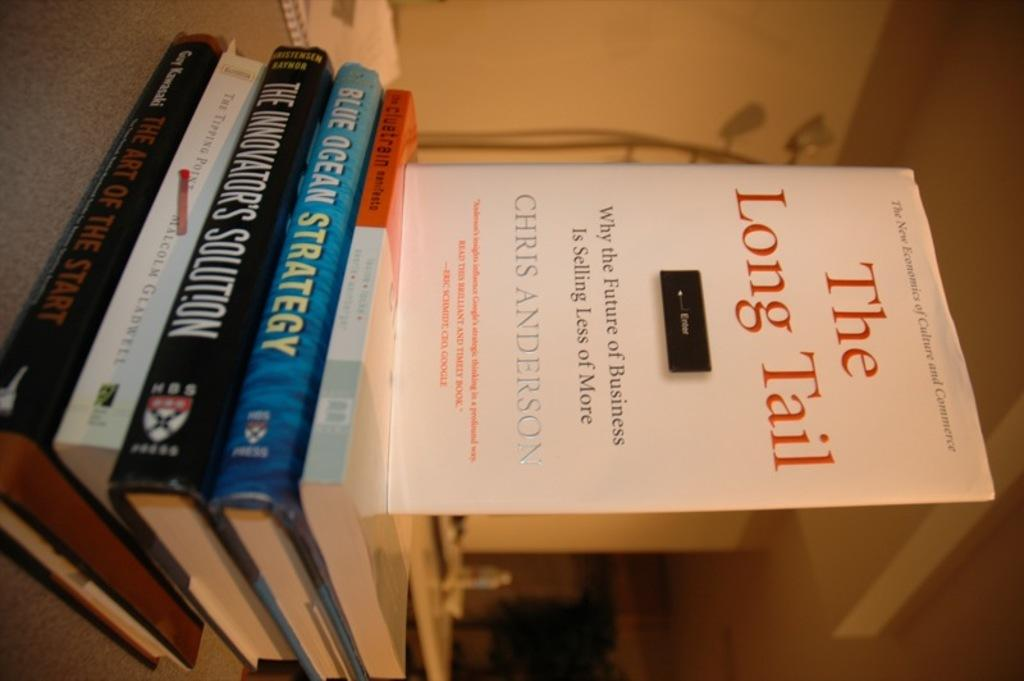<image>
Render a clear and concise summary of the photo. A book titled "The long tail" by Chris Anderson. 